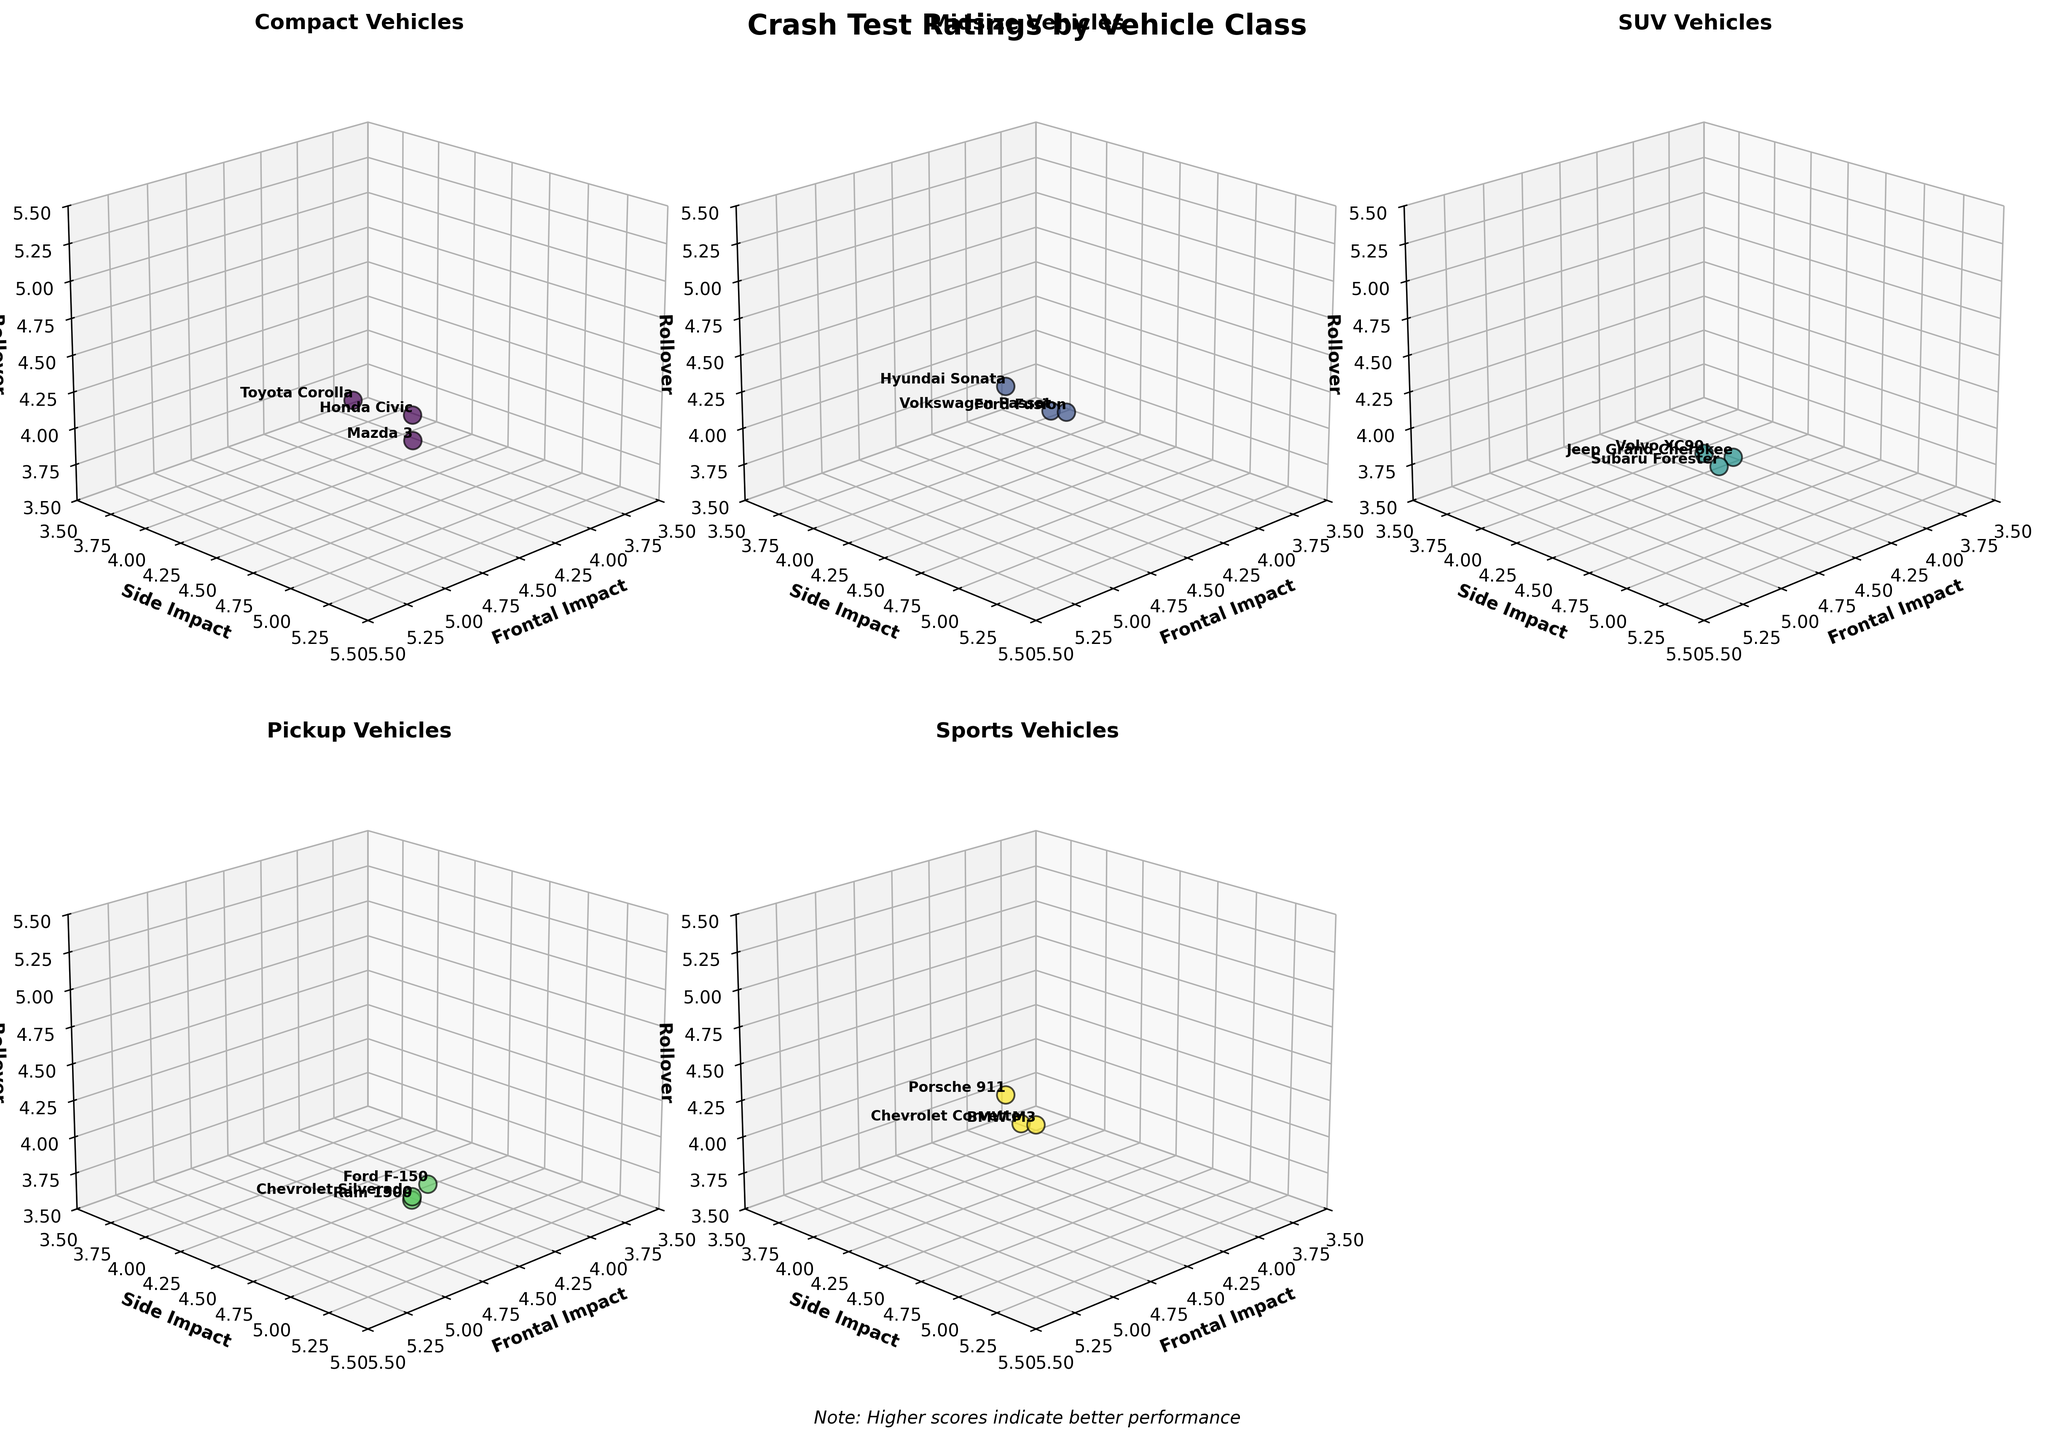What is the title of the plot? The title of the plot is located at the top of the figure and summarizes what the plot represents. It has been set as 'Crash Test Ratings by Vehicle Class'.
Answer: Crash Test Ratings by Vehicle Class Which vehicle class has the highest average Frontal Impact score? We need to average the Frontal Impact scores for each vehicle class. For Compact: (4.5 + 4.7 + 4.6)/3, Midsize: (4.8 + 4.9 + 4.7)/3, SUV: (4.4 + 5.0 + 4.8)/3, Pickup: (4.6 + 4.5 + 4.4)/3, Sports: (4.9 + 4.7 + 4.8)/3. The highest average score is for SUV and Sports, which both average to 4.8.
Answer: SUV and Sports Which vehicle model has the lowest Rollover score? To find the lowest Rollover score, we examine all data points in the plot. The model with the lowest score (3.6) is the Ram 1500.
Answer: Ram 1500 How do the Volvo XC90's scores compare to other SUVs? We need to locate the Volvo XC90 in the SUV subplot and compare its scores with other SUVs in the same subplot. The Volvo XC90 has scores of 5.0 (Frontal Impact), 5.0 (Side Impact), and 4.2 (Rollover), which are the highest for Frontal and Side Impact among SUVs. The only score less in Rollover among SUVs is for Jeep Grand Cherokee (3.8) and Subaru Forester (4.0).
Answer: Highest in Frontal and Side Impact, lower Rollover What are the axis labels of the 3D subplots? Each subplot shares the same axis labels. The x-axis is labeled 'Frontal Impact', the y-axis is labeled 'Side Impact', and the z-axis is labeled 'Rollover'.
Answer: Frontal Impact, Side Impact, Rollover Which vehicle class shows the highest variability in Rollover scores? To determine this, we need to examine the range of Rollover scores for each class. Compact: 4.1 - 4.3, Midsize: 4.3 - 4.5, SUV: 3.8 - 4.2, Pickup: 3.6 - 3.9, Sports: 4.2 - 4.5. The SUV class has the highest variability (range: 3.8 to 4.2).
Answer: SUV Which sports vehicle has the best overall crash test scores (considering all three dimensions)? We need to evaluate the scores along all three axes for each sports vehicle and identify the one with the highest overall scores. This includes Porsche 911 with (4.9, 4.7, 4.5), Chevrolet Corvette with (4.7, 4.6, 4.2), and BMW M3 with (4.8, 4.8, 4.3). Porsche 911 has the highest scores overall.
Answer: Porsche 911 Is there any vehicle class where all models have a similar performance in any of the crash test dimensions? We look for classes where scores in one dimension are consistent. For example, the Side Impact scores of SUVs are 4.6, 5.0, and 4.9, which are fairly close but not identical. Compact cars have Side Impact scores of 4.8, 4.6, and 4.9, also close but not identical. On close inspection, no class has identical scores in any dimension, though some are close.
Answer: None 